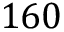<formula> <loc_0><loc_0><loc_500><loc_500>1 6 0</formula> 